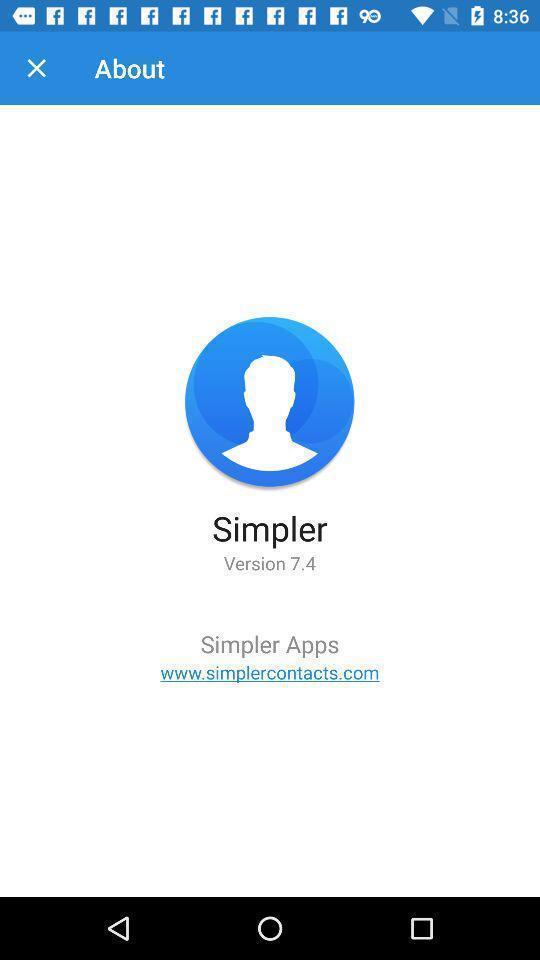Provide a description of this screenshot. Screen displays version. 